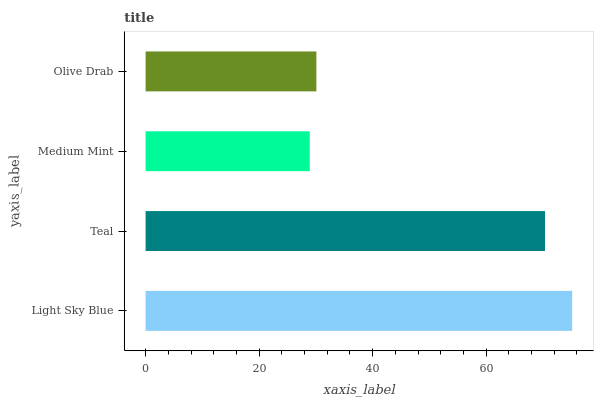Is Medium Mint the minimum?
Answer yes or no. Yes. Is Light Sky Blue the maximum?
Answer yes or no. Yes. Is Teal the minimum?
Answer yes or no. No. Is Teal the maximum?
Answer yes or no. No. Is Light Sky Blue greater than Teal?
Answer yes or no. Yes. Is Teal less than Light Sky Blue?
Answer yes or no. Yes. Is Teal greater than Light Sky Blue?
Answer yes or no. No. Is Light Sky Blue less than Teal?
Answer yes or no. No. Is Teal the high median?
Answer yes or no. Yes. Is Olive Drab the low median?
Answer yes or no. Yes. Is Olive Drab the high median?
Answer yes or no. No. Is Teal the low median?
Answer yes or no. No. 